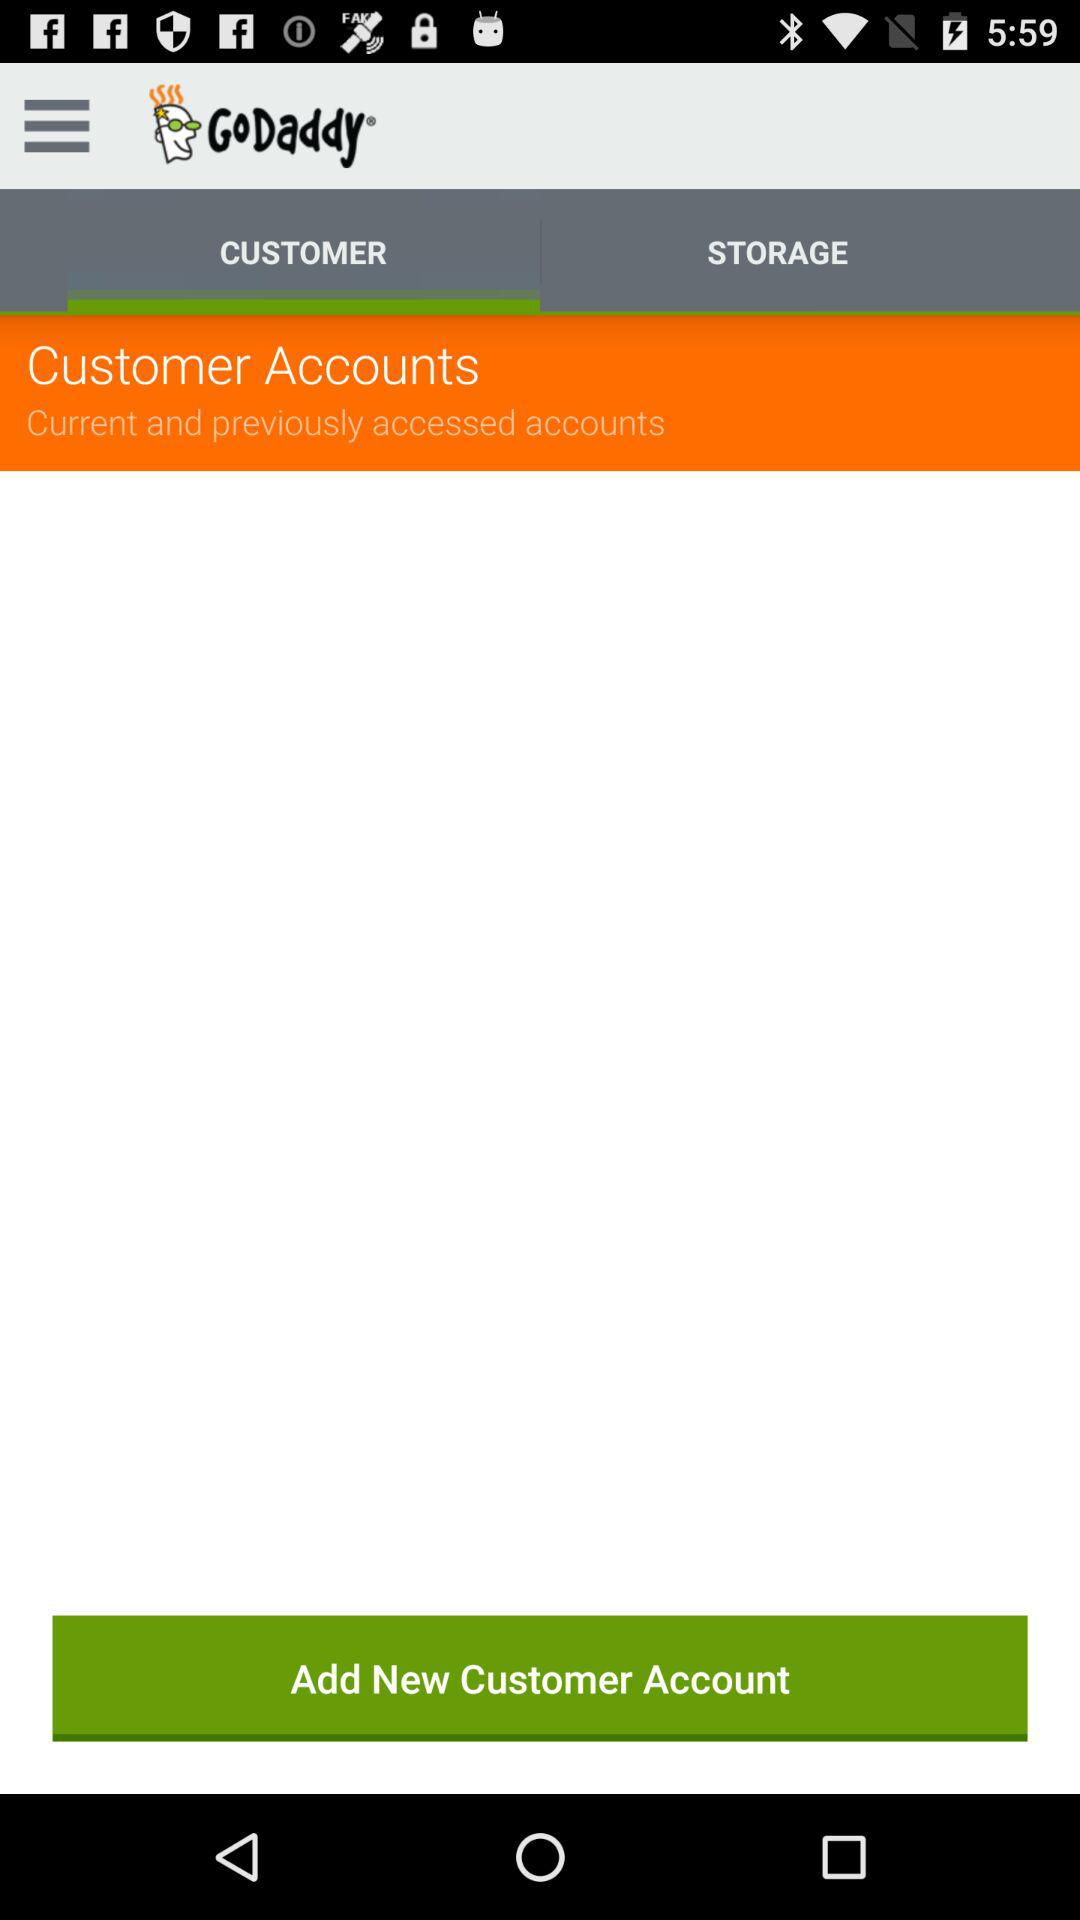Which tab has been selected? The selected tab is "CUSTOMER". 